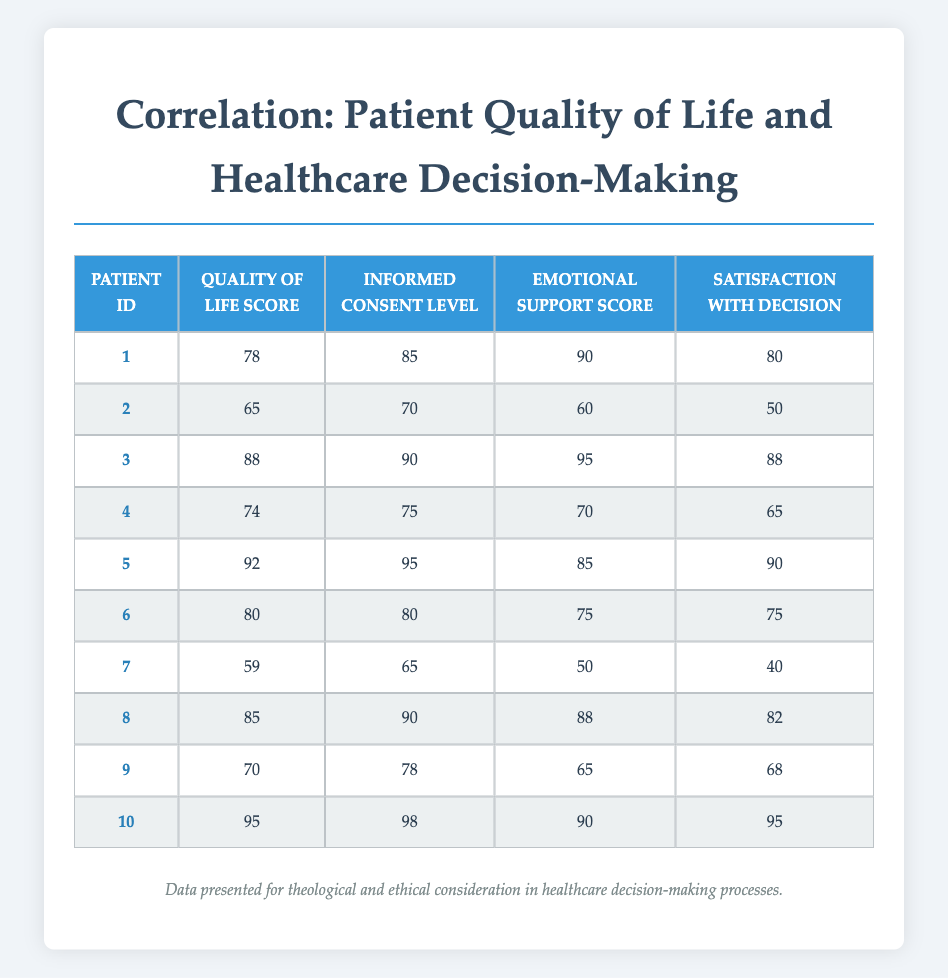What is the highest Quality of Life Score in the data? Looking through the "Quality of Life Score" column, the highest value listed is 95 for Patient 10.
Answer: 95 What is the Satisfaction with Decision score for Patient 3? Referring directly to the table, Patient 3 has a "Satisfaction with Decision" score of 88.
Answer: 88 Which patient has the lowest Emotional Support Score? Scanning the "Emotional Support Score" column, Patient 7 has the lowest score of 50.
Answer: 50 What is the average Informed Consent Level for patients with a Quality of Life Score above 80? First, identify patients with Quality of Life Scores above 80 (Patients 3, 5, 8, and 10). Their Informed Consent Levels are 90, 95, 90, and 98, respectively. The sum is 373, and the average is 373/4 = 93.25.
Answer: 93.25 Is there a correlation between higher Emotional Support Scores and Satisfaction with Decision scores? To evaluate this, we can observe the scores side by side in the table. For most patients with higher Emotional Support Scores (like Patient 3 and Patient 5), the Satisfaction with Decision scores are also high, which suggests a positive correlation.
Answer: Yes What is the difference between the highest and lowest Informed Consent Levels? The highest Informed Consent Level is 98 (Patient 10), and the lowest is 65 (Patient 7). The difference is 98 - 65 = 33.
Answer: 33 Do any patients have a Satisfaction with Decision score lower than their Emotional Support Score? Only Patients 6 and 7 have lower Satisfaction with Decision scores (75 and 40) compared to their Emotional Support Scores (75 and 50). Therefore, the answer is yes for these patients.
Answer: Yes What is the total Quality of Life Score for all patients combined? Adding the Quality of Life Scores from all patients: 78 + 65 + 88 + 74 + 92 + 80 + 59 + 85 + 70 + 95 = 785.
Answer: 785 Which patient has a score of 50 in Satisfaction with Decision? Observing the table, Patient 2 has a "Satisfaction with Decision" score of 50.
Answer: Patient 2 